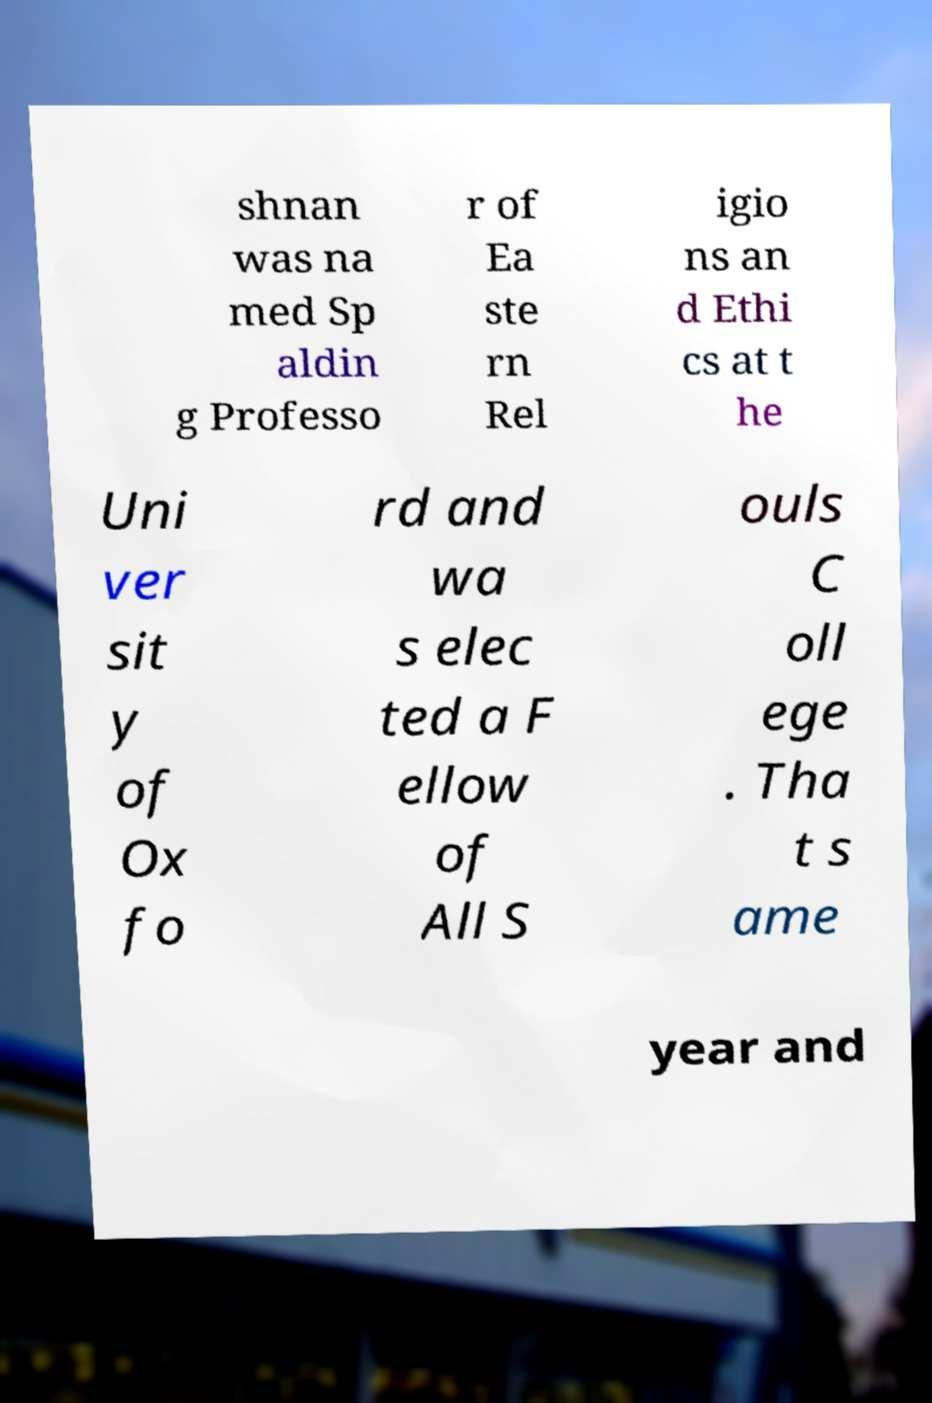Can you accurately transcribe the text from the provided image for me? shnan was na med Sp aldin g Professo r of Ea ste rn Rel igio ns an d Ethi cs at t he Uni ver sit y of Ox fo rd and wa s elec ted a F ellow of All S ouls C oll ege . Tha t s ame year and 